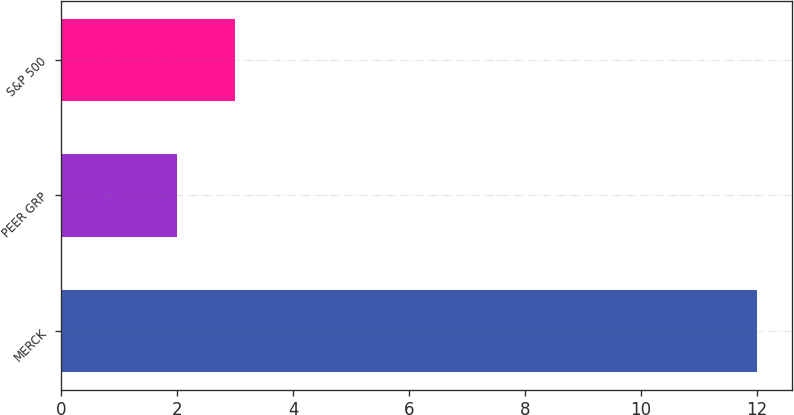<chart> <loc_0><loc_0><loc_500><loc_500><bar_chart><fcel>MERCK<fcel>PEER GRP<fcel>S&P 500<nl><fcel>12<fcel>2<fcel>3<nl></chart> 